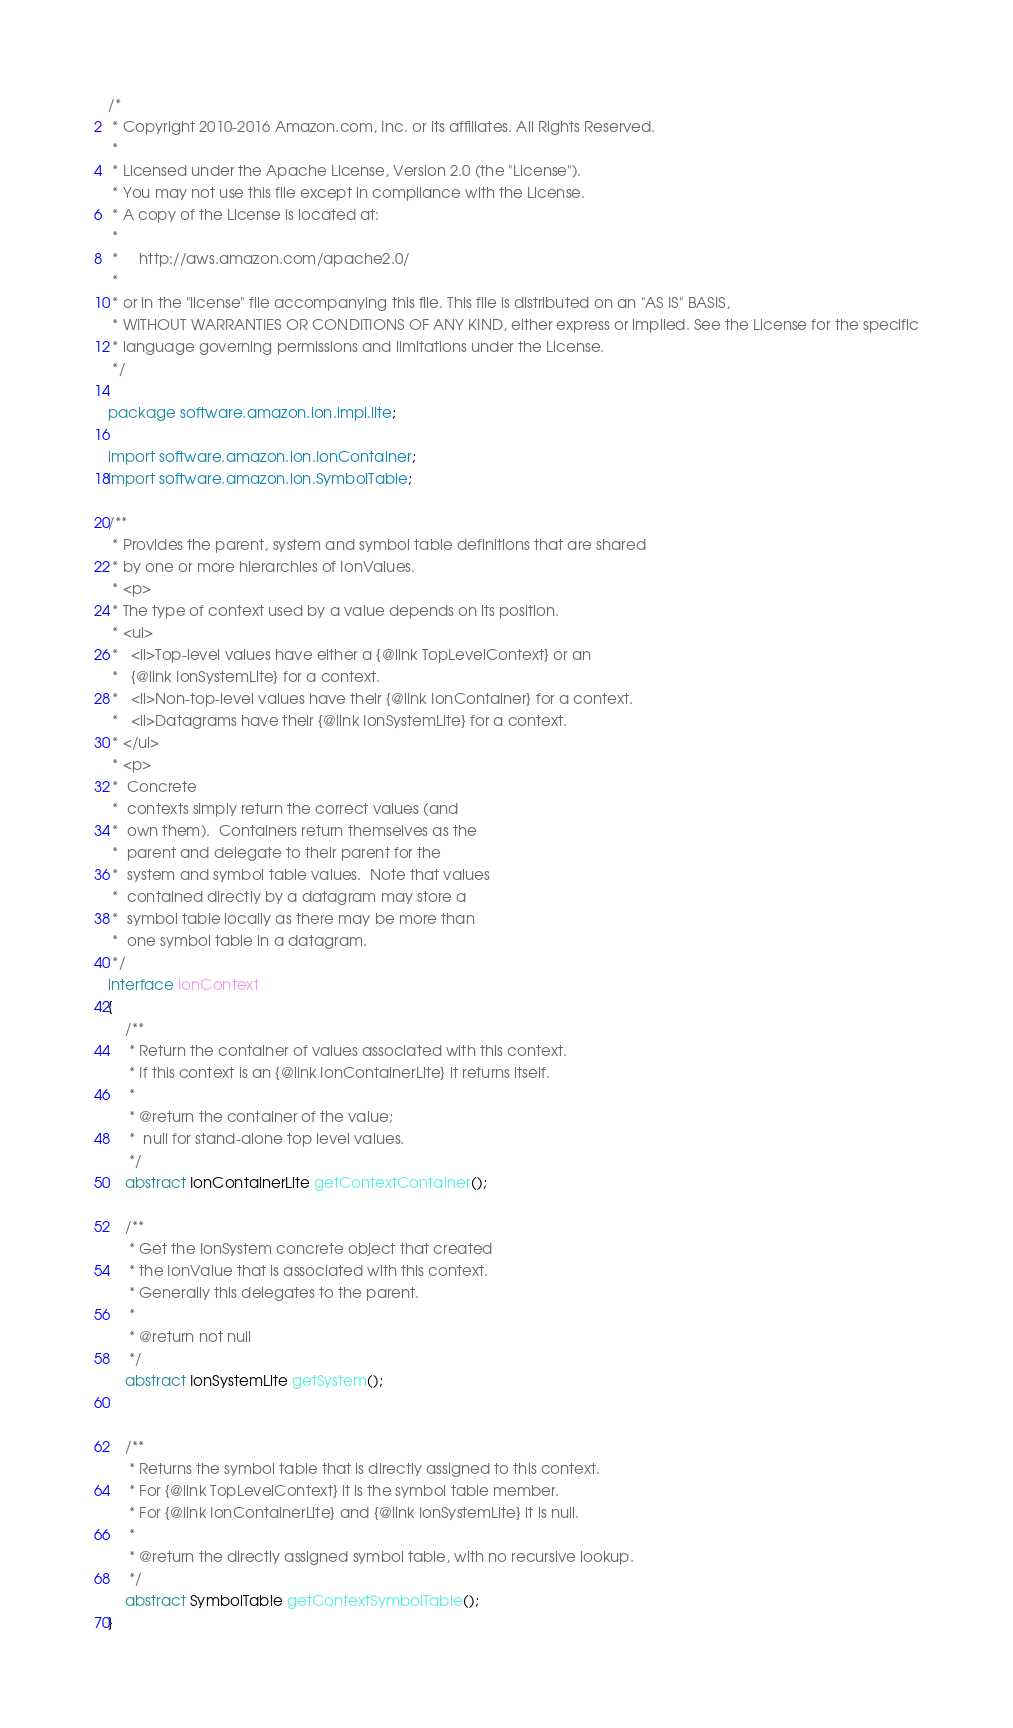<code> <loc_0><loc_0><loc_500><loc_500><_Java_>/*
 * Copyright 2010-2016 Amazon.com, Inc. or its affiliates. All Rights Reserved.
 *
 * Licensed under the Apache License, Version 2.0 (the "License").
 * You may not use this file except in compliance with the License.
 * A copy of the License is located at:
 *
 *     http://aws.amazon.com/apache2.0/
 *
 * or in the "license" file accompanying this file. This file is distributed on an "AS IS" BASIS,
 * WITHOUT WARRANTIES OR CONDITIONS OF ANY KIND, either express or implied. See the License for the specific
 * language governing permissions and limitations under the License.
 */

package software.amazon.ion.impl.lite;

import software.amazon.ion.IonContainer;
import software.amazon.ion.SymbolTable;

/**
 * Provides the parent, system and symbol table definitions that are shared
 * by one or more hierarchies of IonValues.
 * <p>
 * The type of context used by a value depends on its position.
 * <ul>
 *   <li>Top-level values have either a {@link TopLevelContext} or an
 *   {@link IonSystemLite} for a context.
 *   <li>Non-top-level values have their {@link IonContainer} for a context.
 *   <li>Datagrams have their {@link IonSystemLite} for a context.
 * </ul>
 * <p>
 *  Concrete
 *  contexts simply return the correct values (and
 *  own them).  Containers return themselves as the
 *  parent and delegate to their parent for the
 *  system and symbol table values.  Note that values
 *  contained directly by a datagram may store a
 *  symbol table locally as there may be more than
 *  one symbol table in a datagram.
 */
interface IonContext
{
    /**
     * Return the container of values associated with this context.
     * If this context is an {@link IonContainerLite} it returns itself.
     *
     * @return the container of the value;
     *  null for stand-alone top level values.
     */
    abstract IonContainerLite getContextContainer();

    /**
     * Get the IonSystem concrete object that created
     * the IonValue that is associated with this context.
     * Generally this delegates to the parent.
     *
     * @return not null
     */
    abstract IonSystemLite getSystem();


    /**
     * Returns the symbol table that is directly assigned to this context.
     * For {@link TopLevelContext} it is the symbol table member.
     * For {@link IonContainerLite} and {@link IonSystemLite} it is null.
     *
     * @return the directly assigned symbol table, with no recursive lookup.
     */
    abstract SymbolTable getContextSymbolTable();
}
</code> 